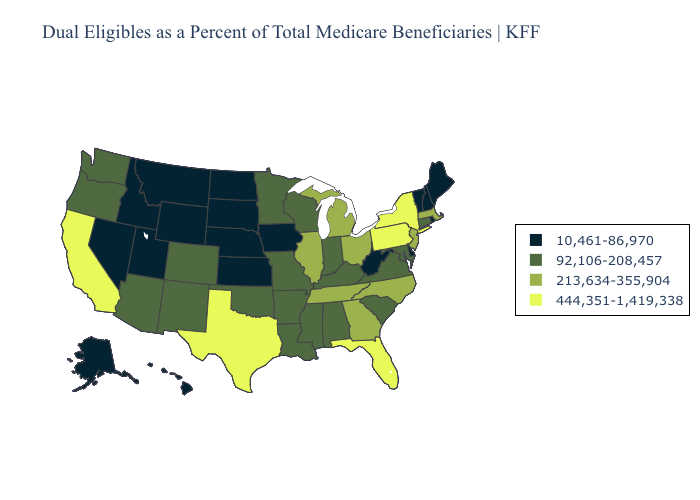Name the states that have a value in the range 213,634-355,904?
Give a very brief answer. Georgia, Illinois, Massachusetts, Michigan, New Jersey, North Carolina, Ohio, Tennessee. Name the states that have a value in the range 213,634-355,904?
Keep it brief. Georgia, Illinois, Massachusetts, Michigan, New Jersey, North Carolina, Ohio, Tennessee. Does Maine have the highest value in the Northeast?
Quick response, please. No. Does South Dakota have a lower value than Oklahoma?
Answer briefly. Yes. What is the highest value in states that border Vermont?
Give a very brief answer. 444,351-1,419,338. What is the value of Florida?
Write a very short answer. 444,351-1,419,338. Which states have the highest value in the USA?
Short answer required. California, Florida, New York, Pennsylvania, Texas. Among the states that border Indiana , which have the highest value?
Give a very brief answer. Illinois, Michigan, Ohio. How many symbols are there in the legend?
Give a very brief answer. 4. Name the states that have a value in the range 213,634-355,904?
Give a very brief answer. Georgia, Illinois, Massachusetts, Michigan, New Jersey, North Carolina, Ohio, Tennessee. What is the value of Delaware?
Be succinct. 10,461-86,970. Does Ohio have a lower value than Louisiana?
Keep it brief. No. What is the lowest value in the MidWest?
Quick response, please. 10,461-86,970. Name the states that have a value in the range 10,461-86,970?
Keep it brief. Alaska, Delaware, Hawaii, Idaho, Iowa, Kansas, Maine, Montana, Nebraska, Nevada, New Hampshire, North Dakota, Rhode Island, South Dakota, Utah, Vermont, West Virginia, Wyoming. What is the highest value in the MidWest ?
Write a very short answer. 213,634-355,904. 